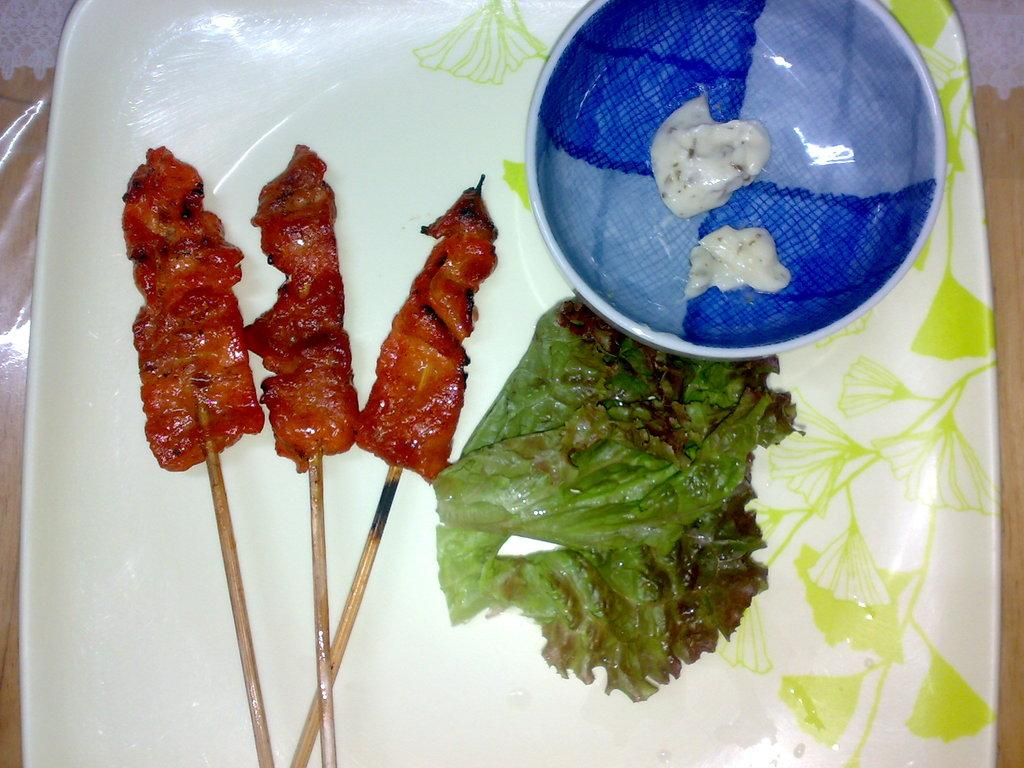What type of food is on the plate in the image? There is a plate with salad in the image. What is the food item with sticks in the image? It is not specified what the food item with sticks is, but it is present in the image. What is in the bowl in the image? There is a bowl with sauce in the image. What can be seen in the background of the image? There is a table in the background of the image. What type of pleasure can be seen enjoying the salad in the image? There is no indication of pleasure or any living being enjoying the salad in the image. 